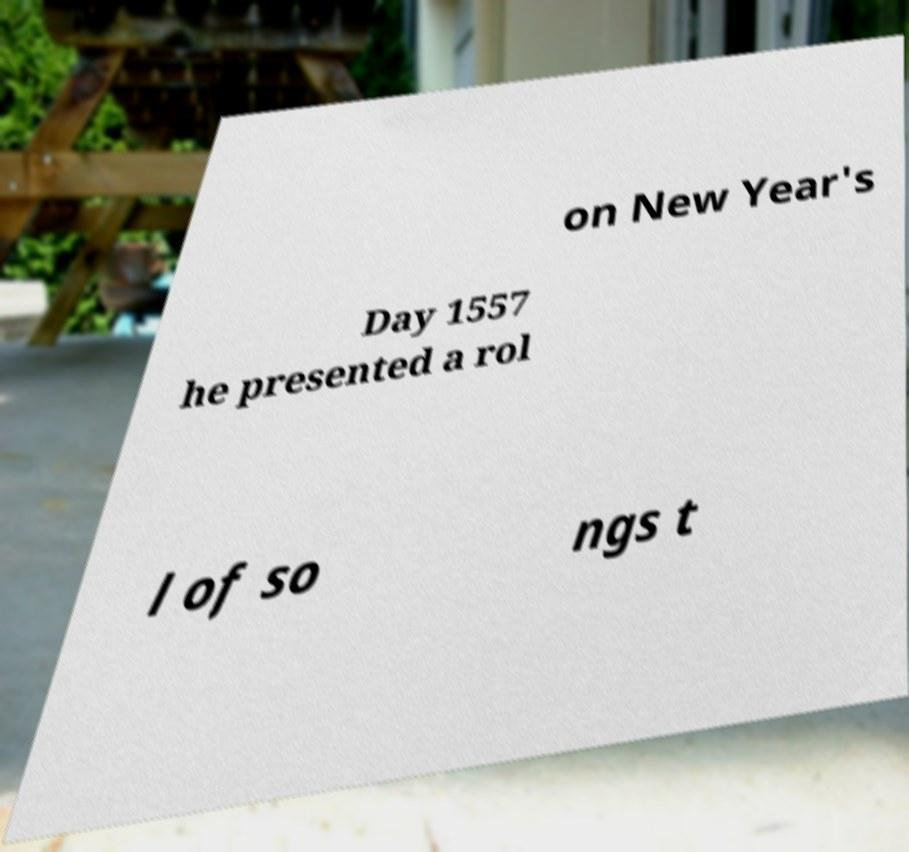Can you read and provide the text displayed in the image?This photo seems to have some interesting text. Can you extract and type it out for me? on New Year's Day 1557 he presented a rol l of so ngs t 